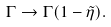Convert formula to latex. <formula><loc_0><loc_0><loc_500><loc_500>\Gamma \rightarrow \Gamma ( 1 - \tilde { \eta } ) .</formula> 